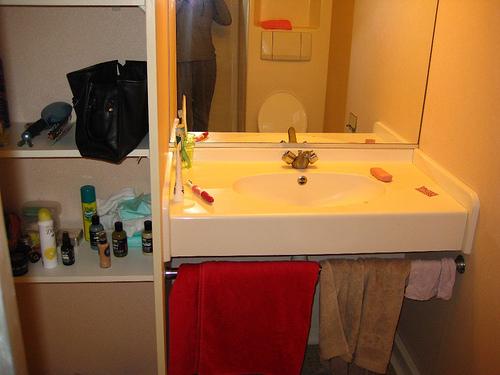Is there a person visible in the mirror?
Give a very brief answer. Yes. Is there soap in the picture?
Short answer required. Yes. What room is shown?
Write a very short answer. Bathroom. 